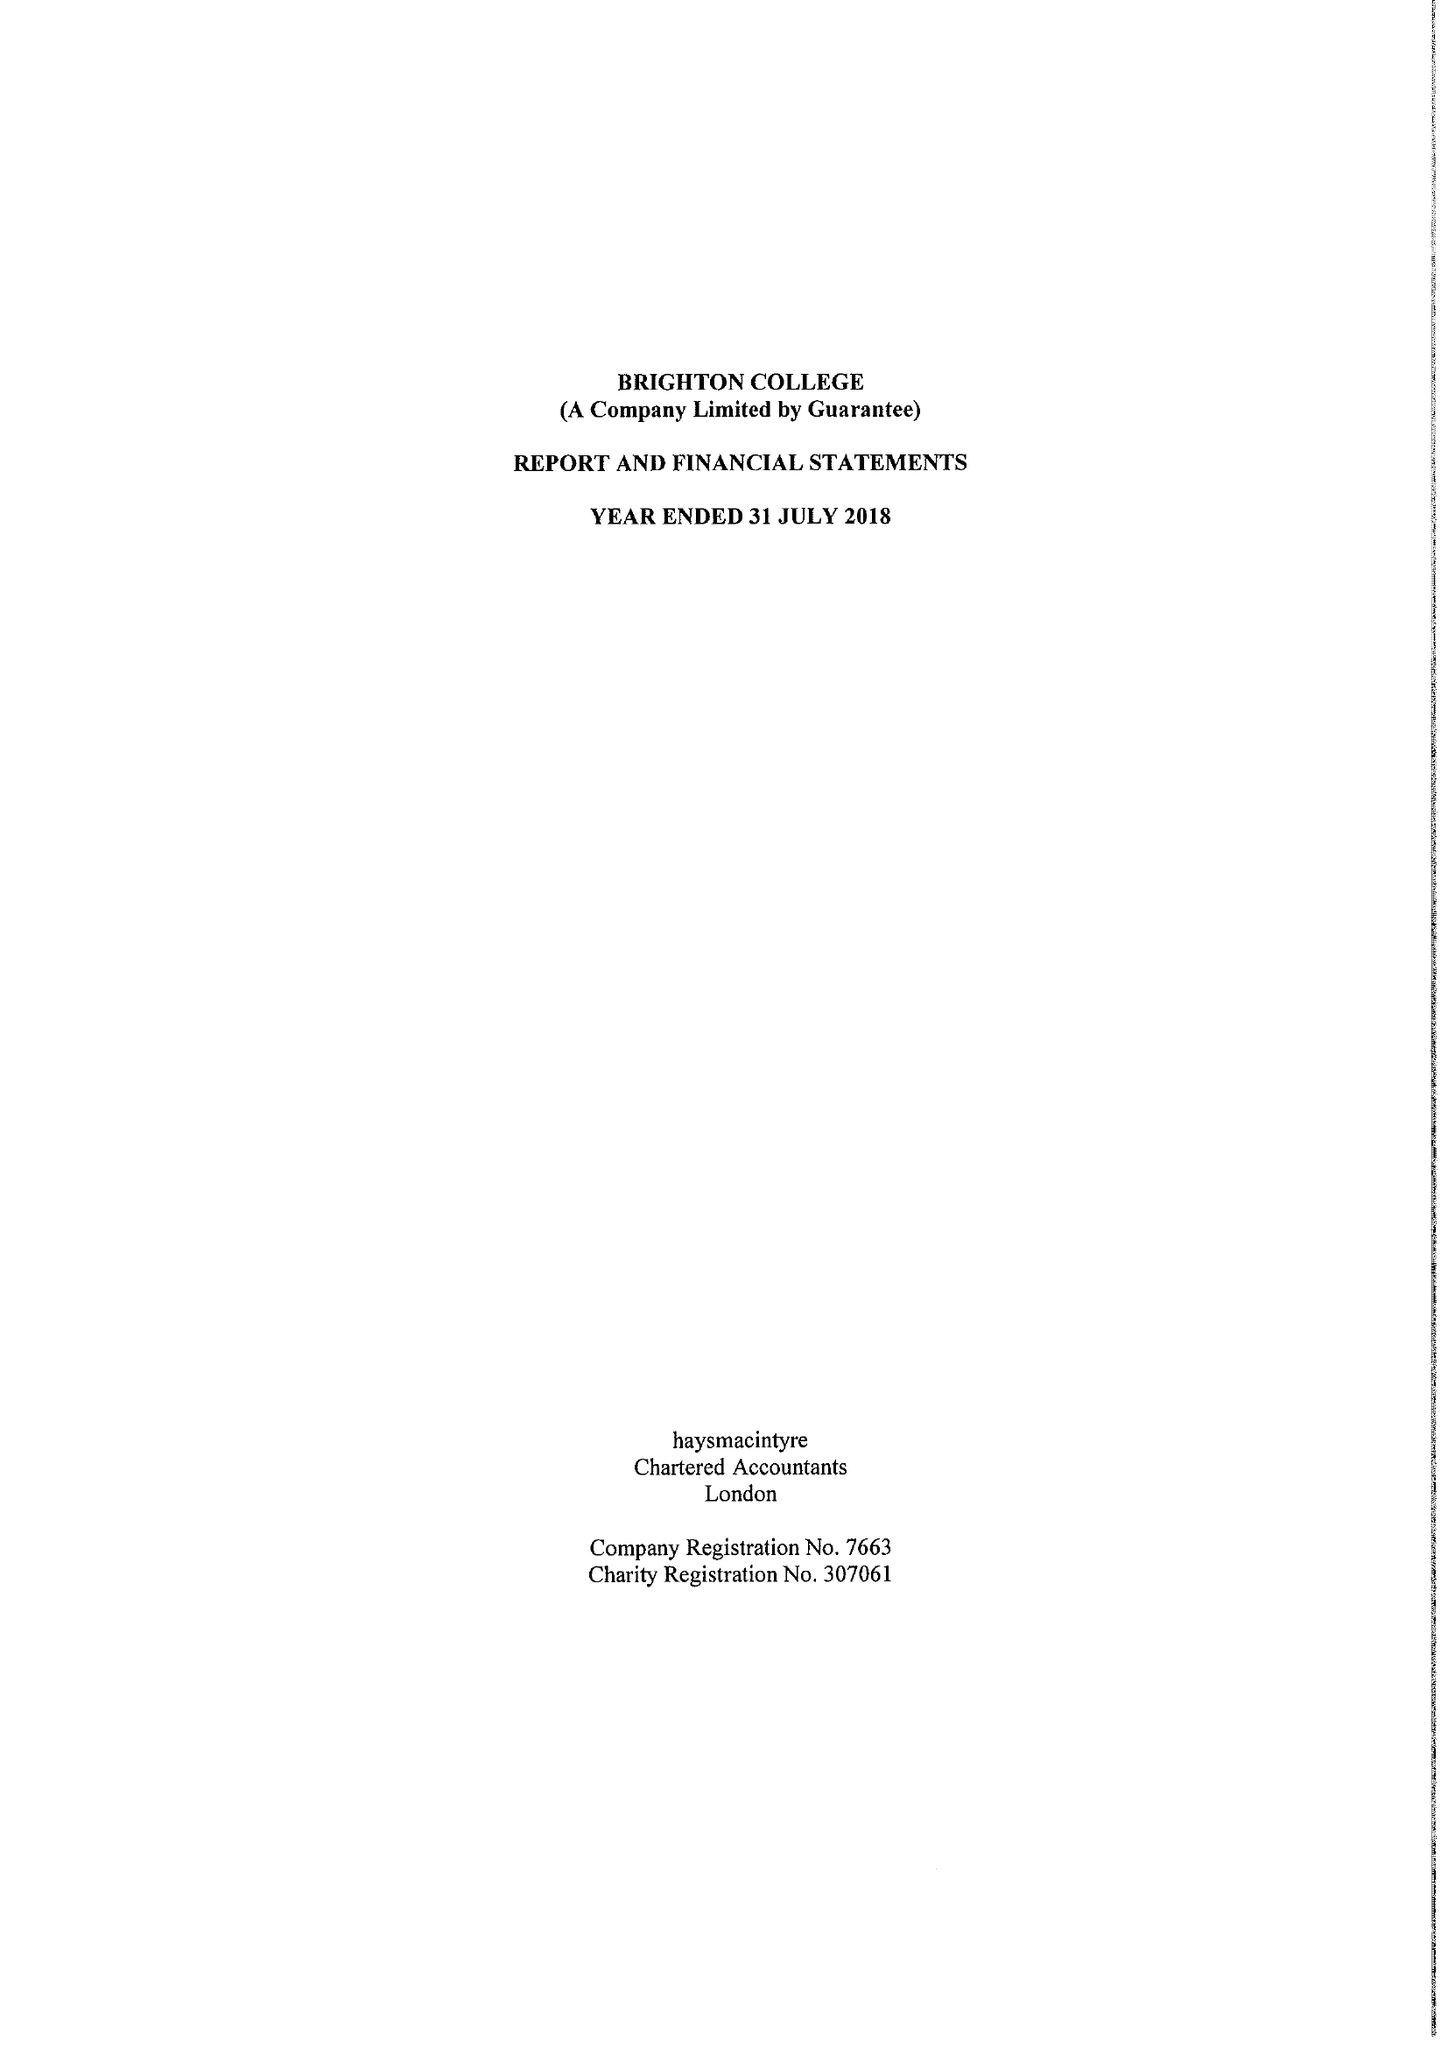What is the value for the address__post_town?
Answer the question using a single word or phrase. BRIGHTON 